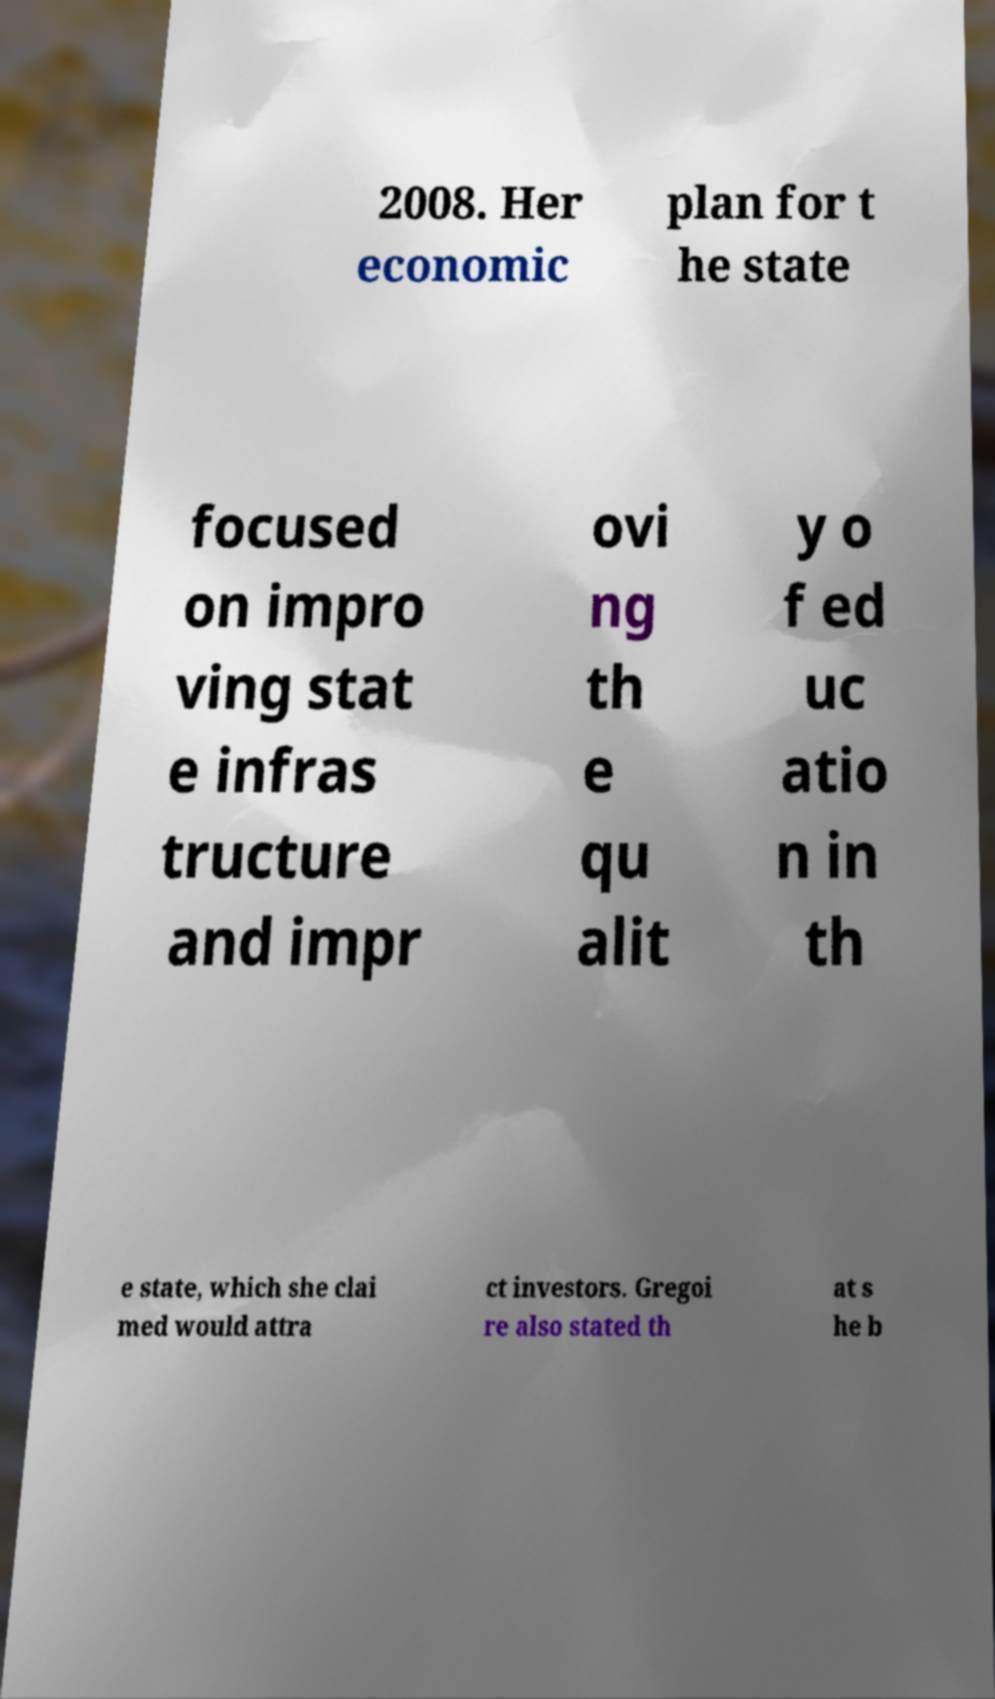Can you accurately transcribe the text from the provided image for me? 2008. Her economic plan for t he state focused on impro ving stat e infras tructure and impr ovi ng th e qu alit y o f ed uc atio n in th e state, which she clai med would attra ct investors. Gregoi re also stated th at s he b 